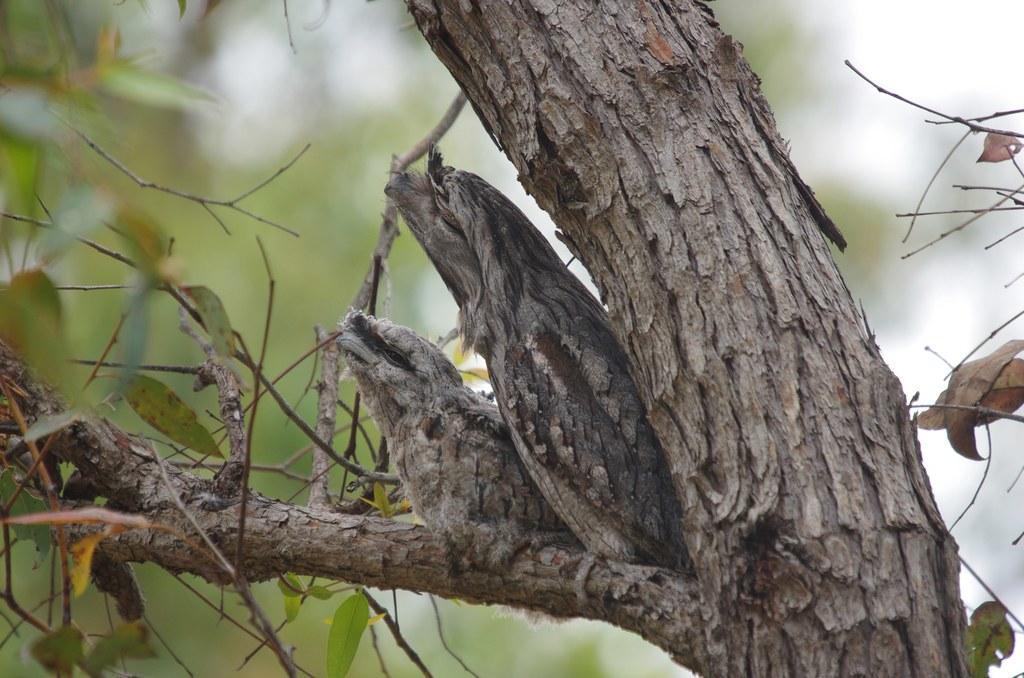Please provide a concise description of this image. In this image we can see birds on the branch of a tree and we can see blurred background. 